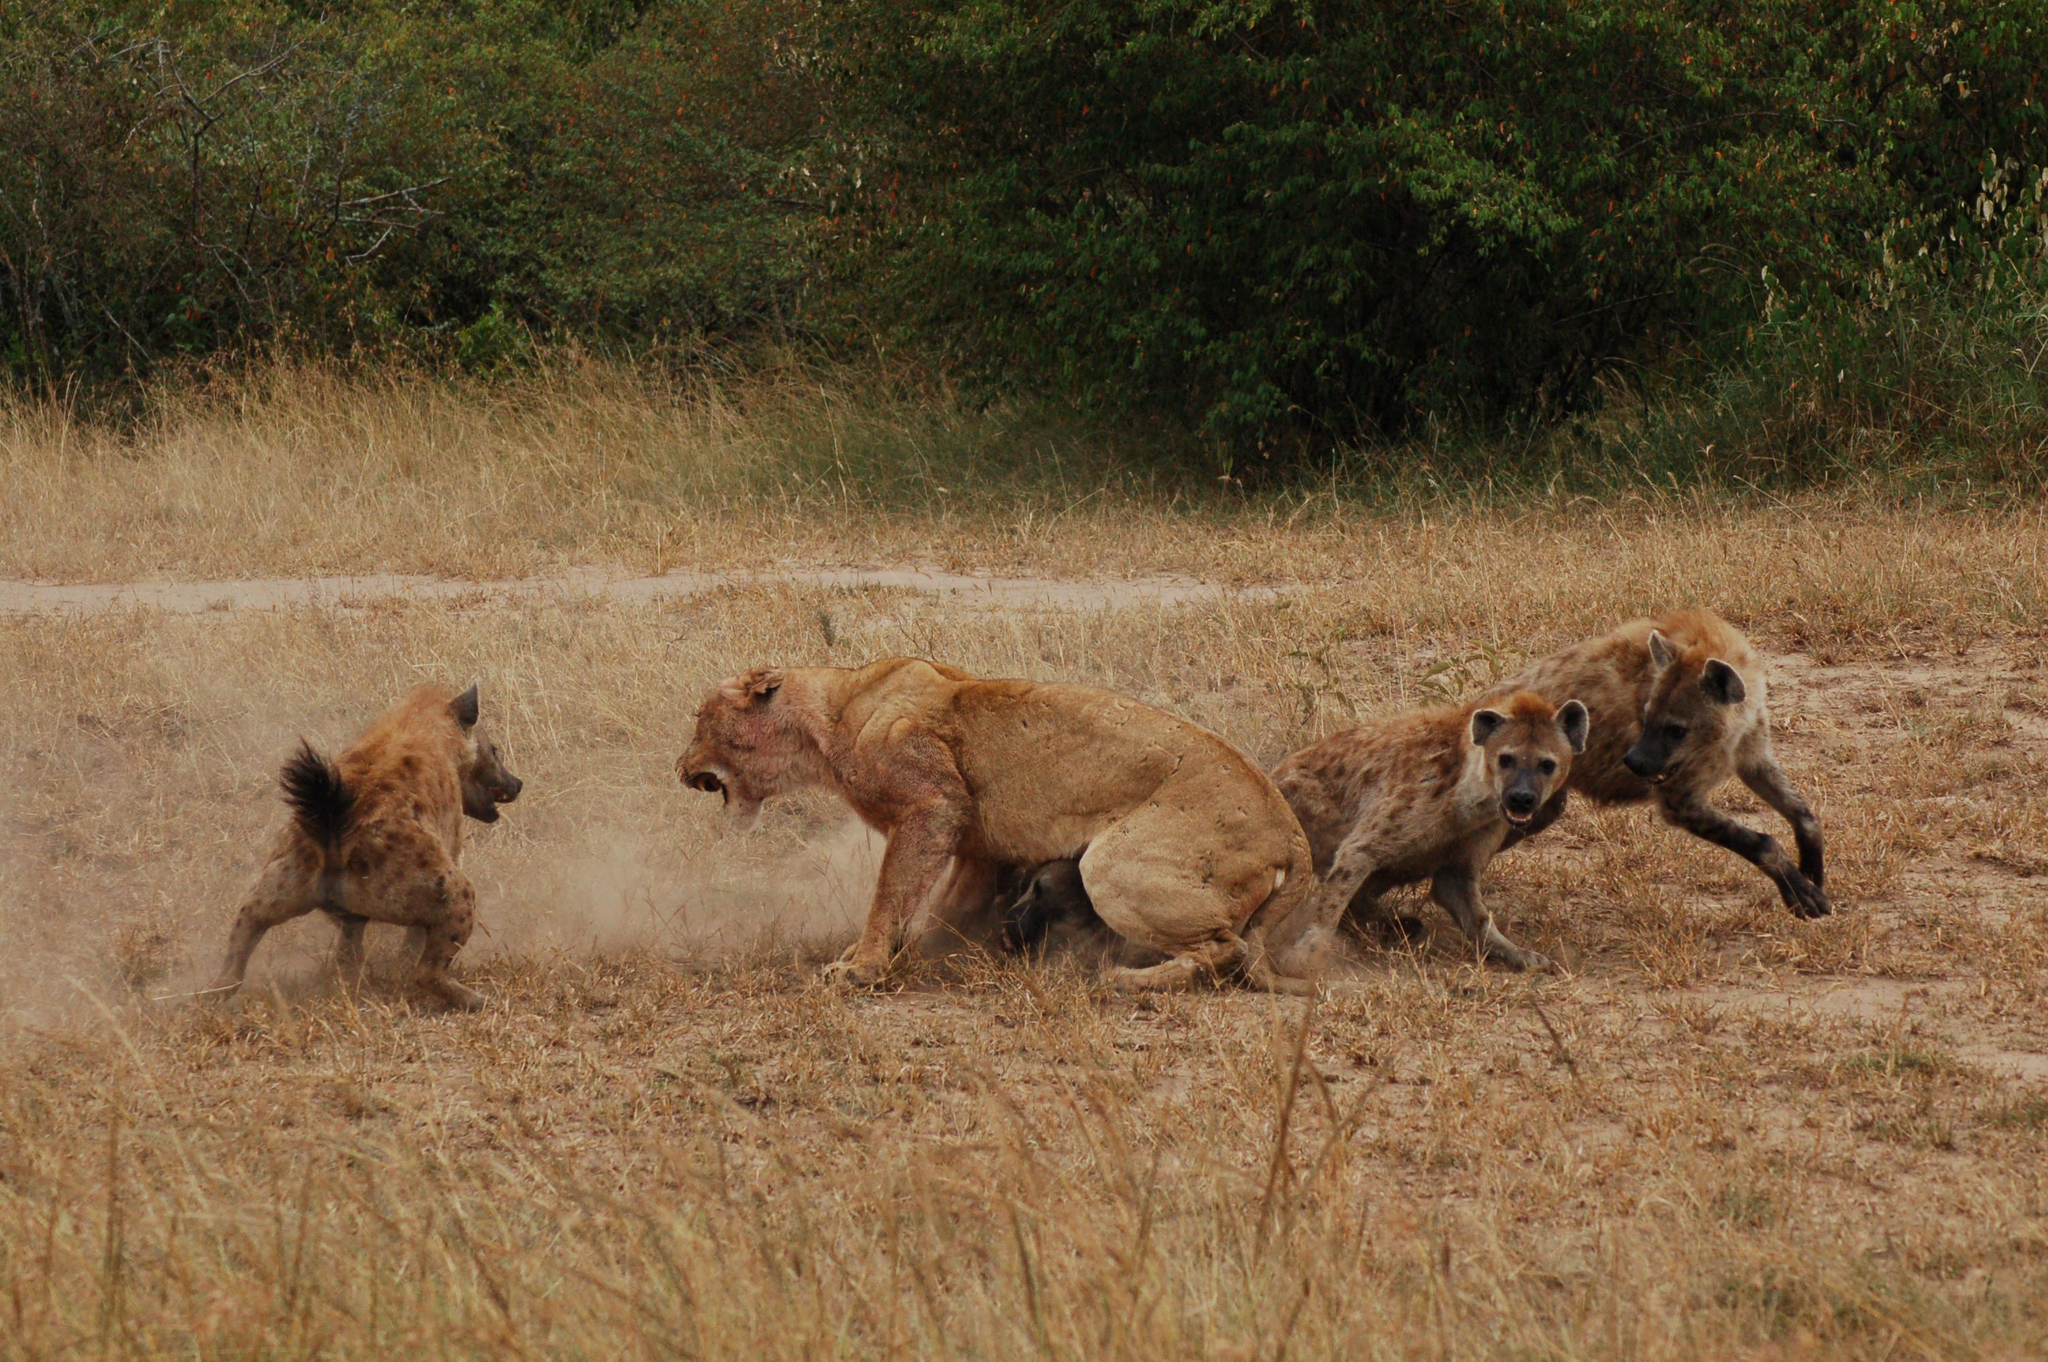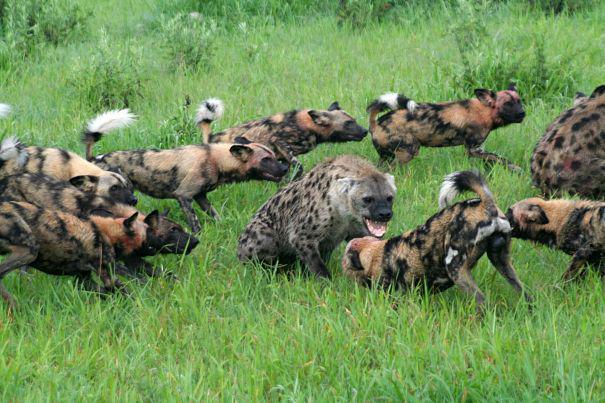The first image is the image on the left, the second image is the image on the right. Evaluate the accuracy of this statement regarding the images: "There are three hyenas in the left image.". Is it true? Answer yes or no. Yes. The first image is the image on the left, the second image is the image on the right. Given the left and right images, does the statement "The lefthand image includes a predator-type non-hooved animal besides a hyena." hold true? Answer yes or no. Yes. 